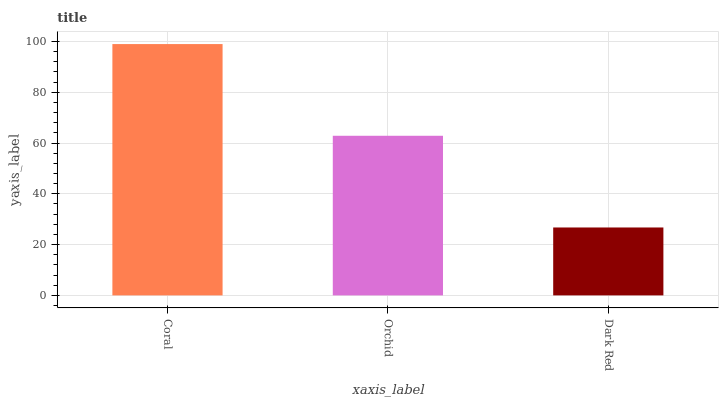Is Orchid the minimum?
Answer yes or no. No. Is Orchid the maximum?
Answer yes or no. No. Is Coral greater than Orchid?
Answer yes or no. Yes. Is Orchid less than Coral?
Answer yes or no. Yes. Is Orchid greater than Coral?
Answer yes or no. No. Is Coral less than Orchid?
Answer yes or no. No. Is Orchid the high median?
Answer yes or no. Yes. Is Orchid the low median?
Answer yes or no. Yes. Is Dark Red the high median?
Answer yes or no. No. Is Dark Red the low median?
Answer yes or no. No. 